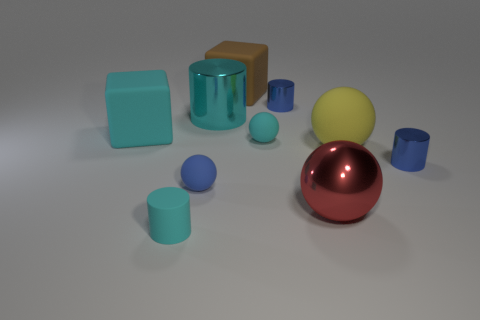Are there any small matte balls that are behind the small blue metallic cylinder to the left of the small blue cylinder that is in front of the big yellow rubber thing?
Your response must be concise. No. What is the shape of the cyan rubber object that is the same size as the brown rubber cube?
Make the answer very short. Cube. What number of big things are cyan things or blue objects?
Offer a terse response. 2. The tiny cylinder that is the same material as the big yellow sphere is what color?
Make the answer very short. Cyan. There is a cyan matte thing that is in front of the large yellow object; does it have the same shape as the metal thing behind the large cyan metal cylinder?
Keep it short and to the point. Yes. How many matte things are either large blocks or tiny brown balls?
Your response must be concise. 2. What material is the block that is the same color as the big metallic cylinder?
Offer a terse response. Rubber. What is the material of the cube that is behind the big cyan cube?
Your answer should be compact. Rubber. Do the big object that is on the right side of the big metal ball and the red sphere have the same material?
Keep it short and to the point. No. How many objects are brown blocks or things left of the brown rubber cube?
Your answer should be compact. 5. 